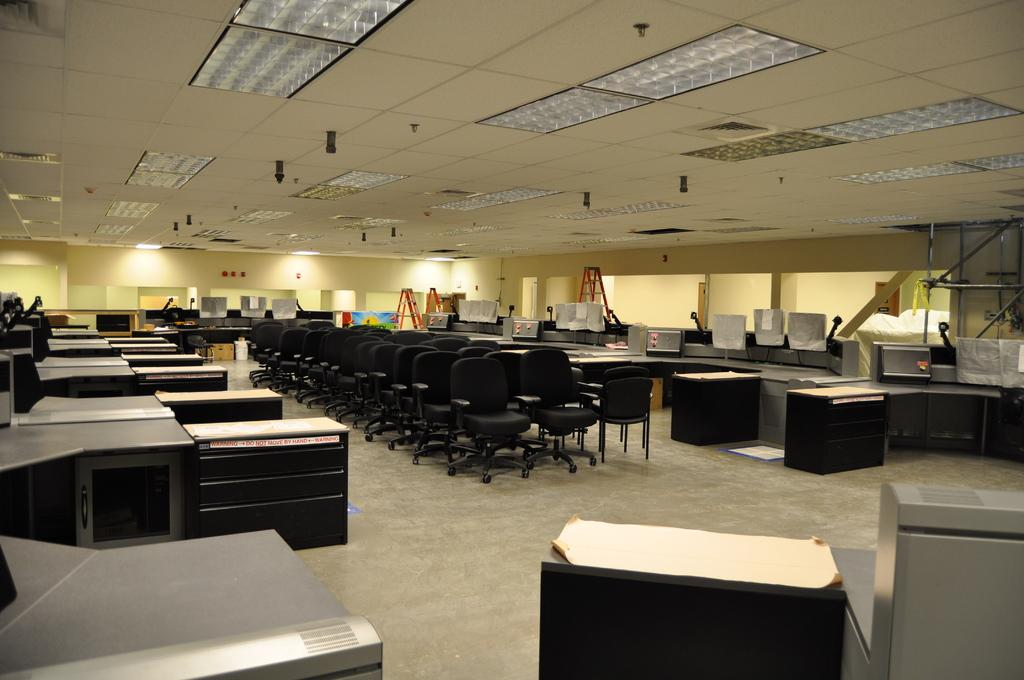What type of furniture can be seen in the image? There are chairs and desks in the image. What is on top of the desks? There are desktops on top of the desks. What is hanging on the walls in the image? There are boards in the image. What type of equipment is present in the image? There are ladders in the image. What part of the room can be seen in the image? The floor is visible in the image. What is visible at the top of the image? The ceiling is visible at the top of the image. What other objects can be seen in the image? Various objects are present in the image. What type of song is being played in the background of the image? There is no indication of any music or sound in the image, so it is impossible to determine if a song is being played. What type of string is attached to the chairs in the image? There is no string attached to the chairs in the image. 